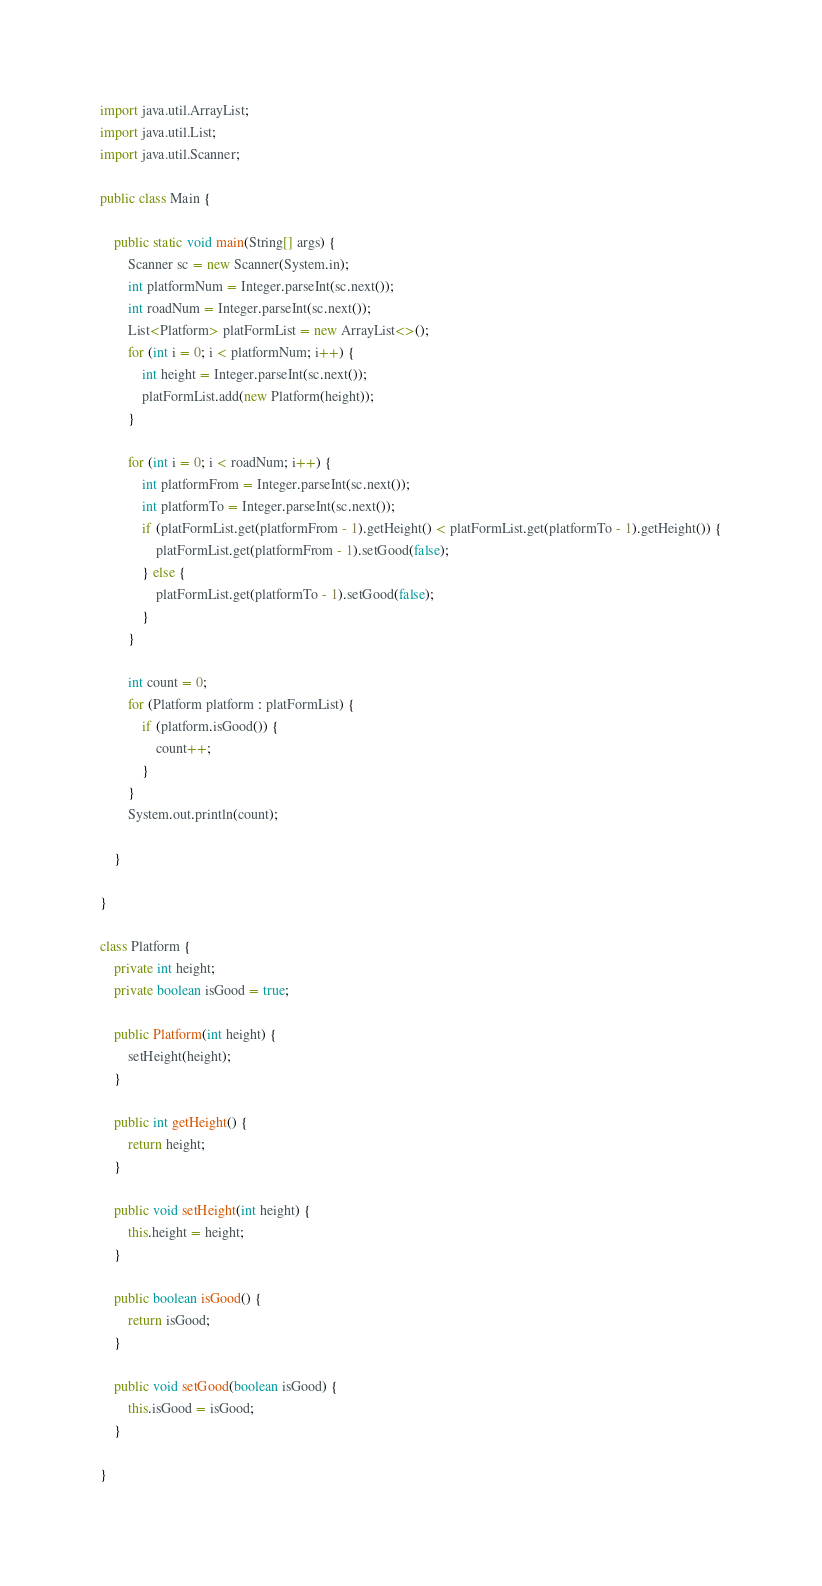Convert code to text. <code><loc_0><loc_0><loc_500><loc_500><_Java_>import java.util.ArrayList;
import java.util.List;
import java.util.Scanner;

public class Main {

	public static void main(String[] args) {
		Scanner sc = new Scanner(System.in);
		int platformNum = Integer.parseInt(sc.next());
		int roadNum = Integer.parseInt(sc.next());
		List<Platform> platFormList = new ArrayList<>();
		for (int i = 0; i < platformNum; i++) {
			int height = Integer.parseInt(sc.next());
			platFormList.add(new Platform(height));
		}

		for (int i = 0; i < roadNum; i++) {
			int platformFrom = Integer.parseInt(sc.next());
			int platformTo = Integer.parseInt(sc.next());
			if (platFormList.get(platformFrom - 1).getHeight() < platFormList.get(platformTo - 1).getHeight()) {
				platFormList.get(platformFrom - 1).setGood(false);
			} else {
				platFormList.get(platformTo - 1).setGood(false);
			}
		}

		int count = 0;
		for (Platform platform : platFormList) {
			if (platform.isGood()) {
				count++;
			}
		}
		System.out.println(count);

	}

}

class Platform {
	private int height;
	private boolean isGood = true;

	public Platform(int height) {
		setHeight(height);
	}

	public int getHeight() {
		return height;
	}

	public void setHeight(int height) {
		this.height = height;
	}

	public boolean isGood() {
		return isGood;
	}

	public void setGood(boolean isGood) {
		this.isGood = isGood;
	}

}
</code> 